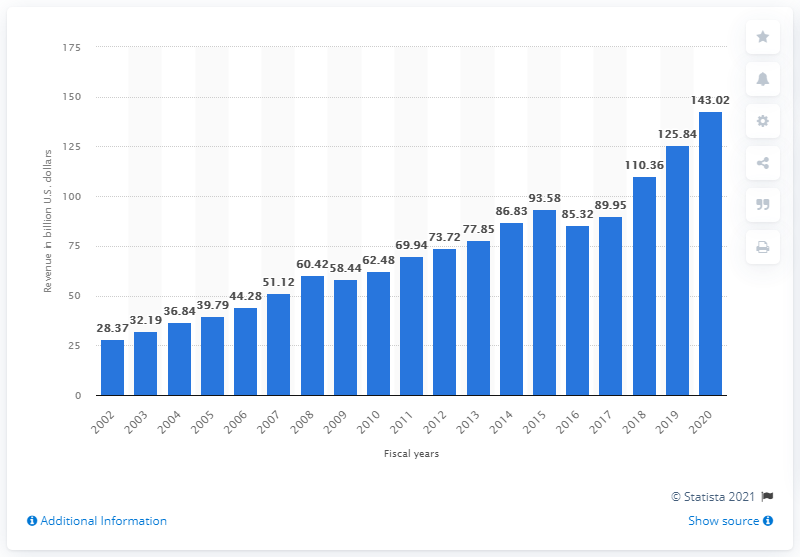List a handful of essential elements in this visual. In 2020, Microsoft's global revenue figures came to an end. In the fiscal year 2020, Microsoft generated a total revenue of 143.02 billion US dollars. In 2002, Microsoft's global revenue was recorded. 